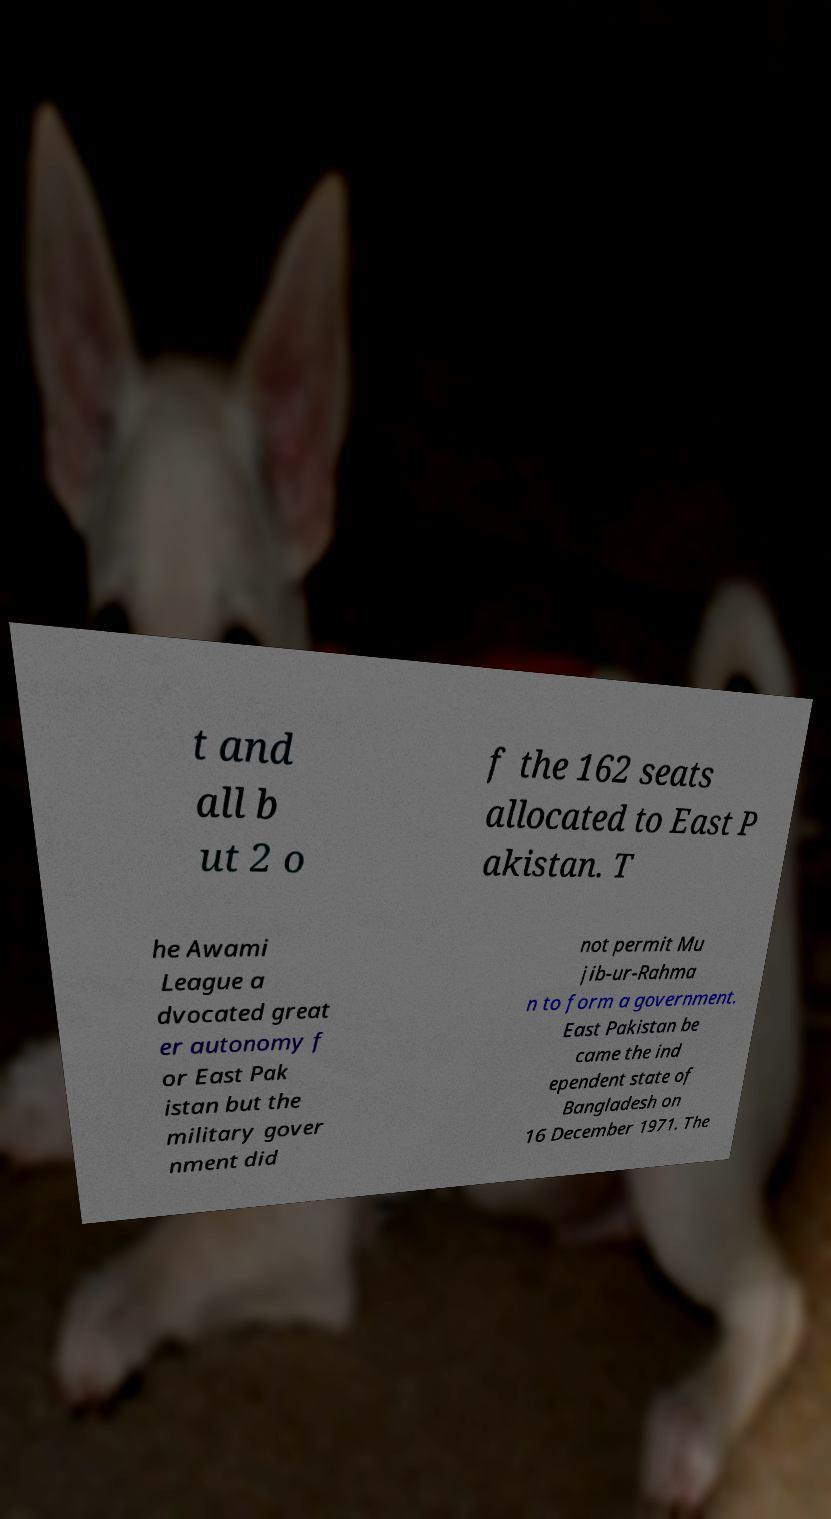For documentation purposes, I need the text within this image transcribed. Could you provide that? t and all b ut 2 o f the 162 seats allocated to East P akistan. T he Awami League a dvocated great er autonomy f or East Pak istan but the military gover nment did not permit Mu jib-ur-Rahma n to form a government. East Pakistan be came the ind ependent state of Bangladesh on 16 December 1971. The 